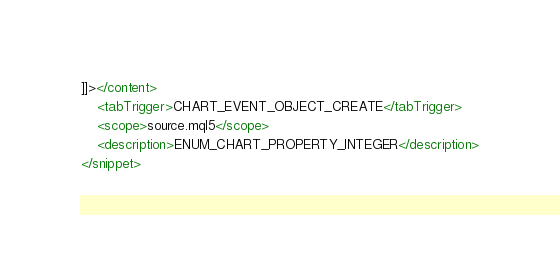<code> <loc_0><loc_0><loc_500><loc_500><_XML_>]]></content>
	<tabTrigger>CHART_EVENT_OBJECT_CREATE</tabTrigger>
	<scope>source.mql5</scope>
	<description>ENUM_CHART_PROPERTY_INTEGER</description>
</snippet>
</code> 